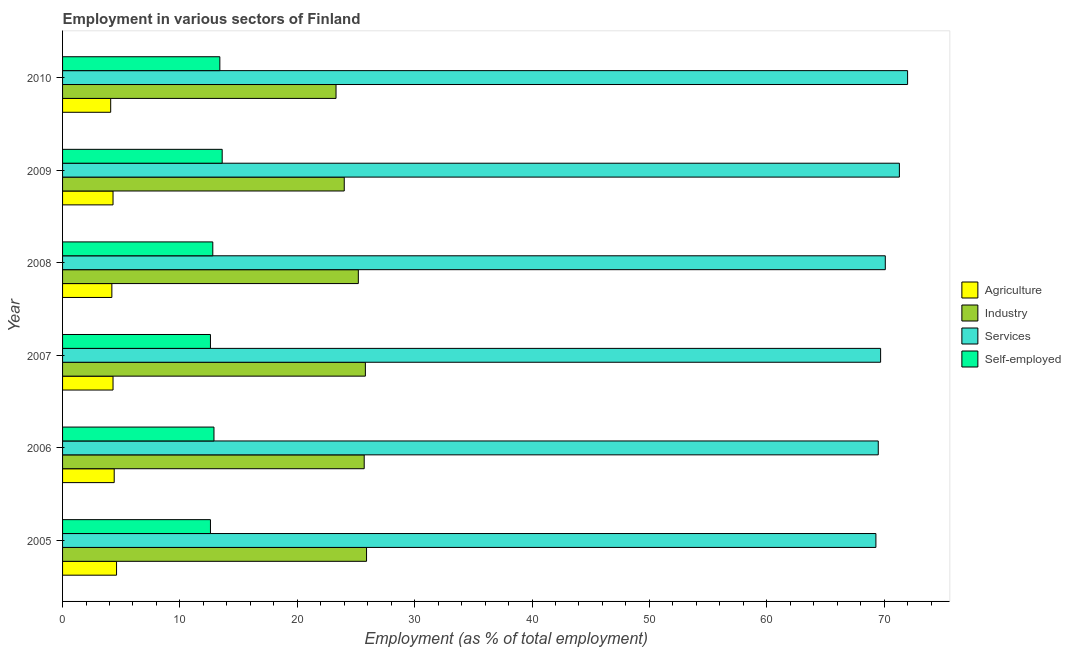How many bars are there on the 5th tick from the bottom?
Provide a succinct answer. 4. What is the percentage of workers in industry in 2005?
Your response must be concise. 25.9. Across all years, what is the maximum percentage of workers in industry?
Your response must be concise. 25.9. Across all years, what is the minimum percentage of workers in services?
Provide a short and direct response. 69.3. In which year was the percentage of workers in agriculture minimum?
Keep it short and to the point. 2010. What is the total percentage of workers in services in the graph?
Keep it short and to the point. 421.9. What is the difference between the percentage of workers in services in 2007 and the percentage of self employed workers in 2006?
Provide a succinct answer. 56.8. What is the average percentage of workers in agriculture per year?
Your response must be concise. 4.32. In the year 2006, what is the difference between the percentage of workers in industry and percentage of workers in agriculture?
Ensure brevity in your answer.  21.3. What is the ratio of the percentage of workers in agriculture in 2009 to that in 2010?
Your response must be concise. 1.05. Is the percentage of workers in agriculture in 2006 less than that in 2010?
Ensure brevity in your answer.  No. What is the difference between the highest and the second highest percentage of workers in industry?
Your response must be concise. 0.1. Is the sum of the percentage of workers in agriculture in 2006 and 2010 greater than the maximum percentage of workers in industry across all years?
Your answer should be compact. No. Is it the case that in every year, the sum of the percentage of workers in agriculture and percentage of workers in services is greater than the sum of percentage of self employed workers and percentage of workers in industry?
Provide a succinct answer. No. What does the 3rd bar from the top in 2010 represents?
Offer a very short reply. Industry. What does the 3rd bar from the bottom in 2010 represents?
Provide a succinct answer. Services. Is it the case that in every year, the sum of the percentage of workers in agriculture and percentage of workers in industry is greater than the percentage of workers in services?
Keep it short and to the point. No. Does the graph contain grids?
Offer a very short reply. No. Where does the legend appear in the graph?
Provide a succinct answer. Center right. How many legend labels are there?
Keep it short and to the point. 4. What is the title of the graph?
Offer a very short reply. Employment in various sectors of Finland. Does "Offering training" appear as one of the legend labels in the graph?
Your answer should be compact. No. What is the label or title of the X-axis?
Your response must be concise. Employment (as % of total employment). What is the Employment (as % of total employment) of Agriculture in 2005?
Make the answer very short. 4.6. What is the Employment (as % of total employment) of Industry in 2005?
Your response must be concise. 25.9. What is the Employment (as % of total employment) of Services in 2005?
Your answer should be compact. 69.3. What is the Employment (as % of total employment) in Self-employed in 2005?
Your answer should be very brief. 12.6. What is the Employment (as % of total employment) in Agriculture in 2006?
Make the answer very short. 4.4. What is the Employment (as % of total employment) of Industry in 2006?
Ensure brevity in your answer.  25.7. What is the Employment (as % of total employment) of Services in 2006?
Ensure brevity in your answer.  69.5. What is the Employment (as % of total employment) in Self-employed in 2006?
Your response must be concise. 12.9. What is the Employment (as % of total employment) in Agriculture in 2007?
Ensure brevity in your answer.  4.3. What is the Employment (as % of total employment) of Industry in 2007?
Give a very brief answer. 25.8. What is the Employment (as % of total employment) of Services in 2007?
Your answer should be compact. 69.7. What is the Employment (as % of total employment) in Self-employed in 2007?
Keep it short and to the point. 12.6. What is the Employment (as % of total employment) of Agriculture in 2008?
Keep it short and to the point. 4.2. What is the Employment (as % of total employment) in Industry in 2008?
Your answer should be compact. 25.2. What is the Employment (as % of total employment) of Services in 2008?
Make the answer very short. 70.1. What is the Employment (as % of total employment) in Self-employed in 2008?
Your response must be concise. 12.8. What is the Employment (as % of total employment) in Agriculture in 2009?
Ensure brevity in your answer.  4.3. What is the Employment (as % of total employment) in Services in 2009?
Provide a succinct answer. 71.3. What is the Employment (as % of total employment) in Self-employed in 2009?
Make the answer very short. 13.6. What is the Employment (as % of total employment) in Agriculture in 2010?
Your response must be concise. 4.1. What is the Employment (as % of total employment) in Industry in 2010?
Give a very brief answer. 23.3. What is the Employment (as % of total employment) of Services in 2010?
Your answer should be very brief. 72. What is the Employment (as % of total employment) of Self-employed in 2010?
Provide a short and direct response. 13.4. Across all years, what is the maximum Employment (as % of total employment) in Agriculture?
Your answer should be compact. 4.6. Across all years, what is the maximum Employment (as % of total employment) of Industry?
Provide a succinct answer. 25.9. Across all years, what is the maximum Employment (as % of total employment) of Services?
Give a very brief answer. 72. Across all years, what is the maximum Employment (as % of total employment) of Self-employed?
Your answer should be compact. 13.6. Across all years, what is the minimum Employment (as % of total employment) in Agriculture?
Make the answer very short. 4.1. Across all years, what is the minimum Employment (as % of total employment) of Industry?
Provide a succinct answer. 23.3. Across all years, what is the minimum Employment (as % of total employment) in Services?
Provide a succinct answer. 69.3. Across all years, what is the minimum Employment (as % of total employment) in Self-employed?
Provide a succinct answer. 12.6. What is the total Employment (as % of total employment) of Agriculture in the graph?
Your answer should be very brief. 25.9. What is the total Employment (as % of total employment) of Industry in the graph?
Provide a succinct answer. 149.9. What is the total Employment (as % of total employment) of Services in the graph?
Keep it short and to the point. 421.9. What is the total Employment (as % of total employment) in Self-employed in the graph?
Your answer should be compact. 77.9. What is the difference between the Employment (as % of total employment) in Agriculture in 2005 and that in 2006?
Provide a succinct answer. 0.2. What is the difference between the Employment (as % of total employment) of Industry in 2005 and that in 2006?
Your response must be concise. 0.2. What is the difference between the Employment (as % of total employment) of Services in 2005 and that in 2006?
Offer a very short reply. -0.2. What is the difference between the Employment (as % of total employment) of Self-employed in 2005 and that in 2008?
Ensure brevity in your answer.  -0.2. What is the difference between the Employment (as % of total employment) in Agriculture in 2005 and that in 2009?
Keep it short and to the point. 0.3. What is the difference between the Employment (as % of total employment) in Industry in 2005 and that in 2009?
Provide a short and direct response. 1.9. What is the difference between the Employment (as % of total employment) of Services in 2005 and that in 2009?
Offer a very short reply. -2. What is the difference between the Employment (as % of total employment) in Self-employed in 2005 and that in 2009?
Your response must be concise. -1. What is the difference between the Employment (as % of total employment) of Agriculture in 2005 and that in 2010?
Make the answer very short. 0.5. What is the difference between the Employment (as % of total employment) of Industry in 2005 and that in 2010?
Your response must be concise. 2.6. What is the difference between the Employment (as % of total employment) of Services in 2005 and that in 2010?
Provide a short and direct response. -2.7. What is the difference between the Employment (as % of total employment) of Self-employed in 2005 and that in 2010?
Provide a short and direct response. -0.8. What is the difference between the Employment (as % of total employment) in Agriculture in 2006 and that in 2007?
Make the answer very short. 0.1. What is the difference between the Employment (as % of total employment) of Industry in 2006 and that in 2007?
Make the answer very short. -0.1. What is the difference between the Employment (as % of total employment) of Services in 2006 and that in 2007?
Your answer should be compact. -0.2. What is the difference between the Employment (as % of total employment) in Agriculture in 2006 and that in 2008?
Your answer should be compact. 0.2. What is the difference between the Employment (as % of total employment) of Industry in 2006 and that in 2008?
Your answer should be very brief. 0.5. What is the difference between the Employment (as % of total employment) in Self-employed in 2006 and that in 2009?
Your answer should be very brief. -0.7. What is the difference between the Employment (as % of total employment) of Agriculture in 2006 and that in 2010?
Your response must be concise. 0.3. What is the difference between the Employment (as % of total employment) of Industry in 2006 and that in 2010?
Offer a very short reply. 2.4. What is the difference between the Employment (as % of total employment) of Self-employed in 2007 and that in 2008?
Keep it short and to the point. -0.2. What is the difference between the Employment (as % of total employment) of Industry in 2007 and that in 2009?
Your answer should be very brief. 1.8. What is the difference between the Employment (as % of total employment) in Services in 2007 and that in 2009?
Provide a succinct answer. -1.6. What is the difference between the Employment (as % of total employment) in Self-employed in 2007 and that in 2009?
Ensure brevity in your answer.  -1. What is the difference between the Employment (as % of total employment) of Agriculture in 2007 and that in 2010?
Ensure brevity in your answer.  0.2. What is the difference between the Employment (as % of total employment) in Industry in 2007 and that in 2010?
Make the answer very short. 2.5. What is the difference between the Employment (as % of total employment) in Services in 2007 and that in 2010?
Provide a succinct answer. -2.3. What is the difference between the Employment (as % of total employment) of Agriculture in 2008 and that in 2009?
Offer a terse response. -0.1. What is the difference between the Employment (as % of total employment) in Agriculture in 2008 and that in 2010?
Ensure brevity in your answer.  0.1. What is the difference between the Employment (as % of total employment) in Services in 2009 and that in 2010?
Offer a very short reply. -0.7. What is the difference between the Employment (as % of total employment) of Self-employed in 2009 and that in 2010?
Your answer should be compact. 0.2. What is the difference between the Employment (as % of total employment) of Agriculture in 2005 and the Employment (as % of total employment) of Industry in 2006?
Make the answer very short. -21.1. What is the difference between the Employment (as % of total employment) of Agriculture in 2005 and the Employment (as % of total employment) of Services in 2006?
Your answer should be very brief. -64.9. What is the difference between the Employment (as % of total employment) of Agriculture in 2005 and the Employment (as % of total employment) of Self-employed in 2006?
Offer a terse response. -8.3. What is the difference between the Employment (as % of total employment) in Industry in 2005 and the Employment (as % of total employment) in Services in 2006?
Provide a succinct answer. -43.6. What is the difference between the Employment (as % of total employment) of Services in 2005 and the Employment (as % of total employment) of Self-employed in 2006?
Provide a short and direct response. 56.4. What is the difference between the Employment (as % of total employment) in Agriculture in 2005 and the Employment (as % of total employment) in Industry in 2007?
Give a very brief answer. -21.2. What is the difference between the Employment (as % of total employment) of Agriculture in 2005 and the Employment (as % of total employment) of Services in 2007?
Provide a short and direct response. -65.1. What is the difference between the Employment (as % of total employment) of Industry in 2005 and the Employment (as % of total employment) of Services in 2007?
Keep it short and to the point. -43.8. What is the difference between the Employment (as % of total employment) in Services in 2005 and the Employment (as % of total employment) in Self-employed in 2007?
Make the answer very short. 56.7. What is the difference between the Employment (as % of total employment) of Agriculture in 2005 and the Employment (as % of total employment) of Industry in 2008?
Provide a short and direct response. -20.6. What is the difference between the Employment (as % of total employment) of Agriculture in 2005 and the Employment (as % of total employment) of Services in 2008?
Your response must be concise. -65.5. What is the difference between the Employment (as % of total employment) in Agriculture in 2005 and the Employment (as % of total employment) in Self-employed in 2008?
Offer a terse response. -8.2. What is the difference between the Employment (as % of total employment) of Industry in 2005 and the Employment (as % of total employment) of Services in 2008?
Provide a short and direct response. -44.2. What is the difference between the Employment (as % of total employment) of Industry in 2005 and the Employment (as % of total employment) of Self-employed in 2008?
Your answer should be very brief. 13.1. What is the difference between the Employment (as % of total employment) of Services in 2005 and the Employment (as % of total employment) of Self-employed in 2008?
Your answer should be very brief. 56.5. What is the difference between the Employment (as % of total employment) in Agriculture in 2005 and the Employment (as % of total employment) in Industry in 2009?
Your answer should be very brief. -19.4. What is the difference between the Employment (as % of total employment) in Agriculture in 2005 and the Employment (as % of total employment) in Services in 2009?
Your response must be concise. -66.7. What is the difference between the Employment (as % of total employment) of Industry in 2005 and the Employment (as % of total employment) of Services in 2009?
Ensure brevity in your answer.  -45.4. What is the difference between the Employment (as % of total employment) in Industry in 2005 and the Employment (as % of total employment) in Self-employed in 2009?
Provide a succinct answer. 12.3. What is the difference between the Employment (as % of total employment) in Services in 2005 and the Employment (as % of total employment) in Self-employed in 2009?
Offer a very short reply. 55.7. What is the difference between the Employment (as % of total employment) in Agriculture in 2005 and the Employment (as % of total employment) in Industry in 2010?
Your answer should be very brief. -18.7. What is the difference between the Employment (as % of total employment) of Agriculture in 2005 and the Employment (as % of total employment) of Services in 2010?
Make the answer very short. -67.4. What is the difference between the Employment (as % of total employment) of Industry in 2005 and the Employment (as % of total employment) of Services in 2010?
Provide a succinct answer. -46.1. What is the difference between the Employment (as % of total employment) of Industry in 2005 and the Employment (as % of total employment) of Self-employed in 2010?
Offer a very short reply. 12.5. What is the difference between the Employment (as % of total employment) of Services in 2005 and the Employment (as % of total employment) of Self-employed in 2010?
Offer a terse response. 55.9. What is the difference between the Employment (as % of total employment) of Agriculture in 2006 and the Employment (as % of total employment) of Industry in 2007?
Your answer should be compact. -21.4. What is the difference between the Employment (as % of total employment) of Agriculture in 2006 and the Employment (as % of total employment) of Services in 2007?
Ensure brevity in your answer.  -65.3. What is the difference between the Employment (as % of total employment) in Agriculture in 2006 and the Employment (as % of total employment) in Self-employed in 2007?
Keep it short and to the point. -8.2. What is the difference between the Employment (as % of total employment) in Industry in 2006 and the Employment (as % of total employment) in Services in 2007?
Offer a terse response. -44. What is the difference between the Employment (as % of total employment) in Industry in 2006 and the Employment (as % of total employment) in Self-employed in 2007?
Provide a short and direct response. 13.1. What is the difference between the Employment (as % of total employment) in Services in 2006 and the Employment (as % of total employment) in Self-employed in 2007?
Keep it short and to the point. 56.9. What is the difference between the Employment (as % of total employment) of Agriculture in 2006 and the Employment (as % of total employment) of Industry in 2008?
Your answer should be very brief. -20.8. What is the difference between the Employment (as % of total employment) of Agriculture in 2006 and the Employment (as % of total employment) of Services in 2008?
Ensure brevity in your answer.  -65.7. What is the difference between the Employment (as % of total employment) of Industry in 2006 and the Employment (as % of total employment) of Services in 2008?
Make the answer very short. -44.4. What is the difference between the Employment (as % of total employment) in Services in 2006 and the Employment (as % of total employment) in Self-employed in 2008?
Your answer should be very brief. 56.7. What is the difference between the Employment (as % of total employment) of Agriculture in 2006 and the Employment (as % of total employment) of Industry in 2009?
Offer a very short reply. -19.6. What is the difference between the Employment (as % of total employment) in Agriculture in 2006 and the Employment (as % of total employment) in Services in 2009?
Ensure brevity in your answer.  -66.9. What is the difference between the Employment (as % of total employment) in Industry in 2006 and the Employment (as % of total employment) in Services in 2009?
Provide a succinct answer. -45.6. What is the difference between the Employment (as % of total employment) in Services in 2006 and the Employment (as % of total employment) in Self-employed in 2009?
Your response must be concise. 55.9. What is the difference between the Employment (as % of total employment) in Agriculture in 2006 and the Employment (as % of total employment) in Industry in 2010?
Offer a terse response. -18.9. What is the difference between the Employment (as % of total employment) of Agriculture in 2006 and the Employment (as % of total employment) of Services in 2010?
Make the answer very short. -67.6. What is the difference between the Employment (as % of total employment) in Agriculture in 2006 and the Employment (as % of total employment) in Self-employed in 2010?
Offer a very short reply. -9. What is the difference between the Employment (as % of total employment) in Industry in 2006 and the Employment (as % of total employment) in Services in 2010?
Offer a very short reply. -46.3. What is the difference between the Employment (as % of total employment) of Services in 2006 and the Employment (as % of total employment) of Self-employed in 2010?
Provide a succinct answer. 56.1. What is the difference between the Employment (as % of total employment) in Agriculture in 2007 and the Employment (as % of total employment) in Industry in 2008?
Your answer should be very brief. -20.9. What is the difference between the Employment (as % of total employment) in Agriculture in 2007 and the Employment (as % of total employment) in Services in 2008?
Provide a short and direct response. -65.8. What is the difference between the Employment (as % of total employment) of Agriculture in 2007 and the Employment (as % of total employment) of Self-employed in 2008?
Provide a succinct answer. -8.5. What is the difference between the Employment (as % of total employment) of Industry in 2007 and the Employment (as % of total employment) of Services in 2008?
Your answer should be compact. -44.3. What is the difference between the Employment (as % of total employment) of Industry in 2007 and the Employment (as % of total employment) of Self-employed in 2008?
Provide a succinct answer. 13. What is the difference between the Employment (as % of total employment) in Services in 2007 and the Employment (as % of total employment) in Self-employed in 2008?
Provide a succinct answer. 56.9. What is the difference between the Employment (as % of total employment) of Agriculture in 2007 and the Employment (as % of total employment) of Industry in 2009?
Ensure brevity in your answer.  -19.7. What is the difference between the Employment (as % of total employment) in Agriculture in 2007 and the Employment (as % of total employment) in Services in 2009?
Offer a very short reply. -67. What is the difference between the Employment (as % of total employment) of Industry in 2007 and the Employment (as % of total employment) of Services in 2009?
Offer a terse response. -45.5. What is the difference between the Employment (as % of total employment) in Services in 2007 and the Employment (as % of total employment) in Self-employed in 2009?
Make the answer very short. 56.1. What is the difference between the Employment (as % of total employment) in Agriculture in 2007 and the Employment (as % of total employment) in Industry in 2010?
Offer a terse response. -19. What is the difference between the Employment (as % of total employment) in Agriculture in 2007 and the Employment (as % of total employment) in Services in 2010?
Your answer should be very brief. -67.7. What is the difference between the Employment (as % of total employment) of Industry in 2007 and the Employment (as % of total employment) of Services in 2010?
Give a very brief answer. -46.2. What is the difference between the Employment (as % of total employment) of Services in 2007 and the Employment (as % of total employment) of Self-employed in 2010?
Offer a terse response. 56.3. What is the difference between the Employment (as % of total employment) of Agriculture in 2008 and the Employment (as % of total employment) of Industry in 2009?
Keep it short and to the point. -19.8. What is the difference between the Employment (as % of total employment) of Agriculture in 2008 and the Employment (as % of total employment) of Services in 2009?
Provide a short and direct response. -67.1. What is the difference between the Employment (as % of total employment) in Industry in 2008 and the Employment (as % of total employment) in Services in 2009?
Provide a succinct answer. -46.1. What is the difference between the Employment (as % of total employment) of Services in 2008 and the Employment (as % of total employment) of Self-employed in 2009?
Your answer should be compact. 56.5. What is the difference between the Employment (as % of total employment) of Agriculture in 2008 and the Employment (as % of total employment) of Industry in 2010?
Offer a terse response. -19.1. What is the difference between the Employment (as % of total employment) in Agriculture in 2008 and the Employment (as % of total employment) in Services in 2010?
Offer a terse response. -67.8. What is the difference between the Employment (as % of total employment) of Agriculture in 2008 and the Employment (as % of total employment) of Self-employed in 2010?
Your response must be concise. -9.2. What is the difference between the Employment (as % of total employment) of Industry in 2008 and the Employment (as % of total employment) of Services in 2010?
Offer a terse response. -46.8. What is the difference between the Employment (as % of total employment) of Services in 2008 and the Employment (as % of total employment) of Self-employed in 2010?
Keep it short and to the point. 56.7. What is the difference between the Employment (as % of total employment) in Agriculture in 2009 and the Employment (as % of total employment) in Industry in 2010?
Offer a terse response. -19. What is the difference between the Employment (as % of total employment) in Agriculture in 2009 and the Employment (as % of total employment) in Services in 2010?
Provide a short and direct response. -67.7. What is the difference between the Employment (as % of total employment) of Industry in 2009 and the Employment (as % of total employment) of Services in 2010?
Your response must be concise. -48. What is the difference between the Employment (as % of total employment) of Services in 2009 and the Employment (as % of total employment) of Self-employed in 2010?
Your answer should be compact. 57.9. What is the average Employment (as % of total employment) in Agriculture per year?
Your response must be concise. 4.32. What is the average Employment (as % of total employment) in Industry per year?
Your response must be concise. 24.98. What is the average Employment (as % of total employment) in Services per year?
Your response must be concise. 70.32. What is the average Employment (as % of total employment) of Self-employed per year?
Provide a succinct answer. 12.98. In the year 2005, what is the difference between the Employment (as % of total employment) of Agriculture and Employment (as % of total employment) of Industry?
Offer a very short reply. -21.3. In the year 2005, what is the difference between the Employment (as % of total employment) in Agriculture and Employment (as % of total employment) in Services?
Keep it short and to the point. -64.7. In the year 2005, what is the difference between the Employment (as % of total employment) in Agriculture and Employment (as % of total employment) in Self-employed?
Offer a terse response. -8. In the year 2005, what is the difference between the Employment (as % of total employment) of Industry and Employment (as % of total employment) of Services?
Make the answer very short. -43.4. In the year 2005, what is the difference between the Employment (as % of total employment) of Services and Employment (as % of total employment) of Self-employed?
Provide a short and direct response. 56.7. In the year 2006, what is the difference between the Employment (as % of total employment) of Agriculture and Employment (as % of total employment) of Industry?
Make the answer very short. -21.3. In the year 2006, what is the difference between the Employment (as % of total employment) of Agriculture and Employment (as % of total employment) of Services?
Your response must be concise. -65.1. In the year 2006, what is the difference between the Employment (as % of total employment) in Agriculture and Employment (as % of total employment) in Self-employed?
Your answer should be very brief. -8.5. In the year 2006, what is the difference between the Employment (as % of total employment) of Industry and Employment (as % of total employment) of Services?
Give a very brief answer. -43.8. In the year 2006, what is the difference between the Employment (as % of total employment) in Services and Employment (as % of total employment) in Self-employed?
Provide a succinct answer. 56.6. In the year 2007, what is the difference between the Employment (as % of total employment) of Agriculture and Employment (as % of total employment) of Industry?
Give a very brief answer. -21.5. In the year 2007, what is the difference between the Employment (as % of total employment) of Agriculture and Employment (as % of total employment) of Services?
Offer a terse response. -65.4. In the year 2007, what is the difference between the Employment (as % of total employment) of Agriculture and Employment (as % of total employment) of Self-employed?
Offer a terse response. -8.3. In the year 2007, what is the difference between the Employment (as % of total employment) of Industry and Employment (as % of total employment) of Services?
Keep it short and to the point. -43.9. In the year 2007, what is the difference between the Employment (as % of total employment) in Industry and Employment (as % of total employment) in Self-employed?
Offer a terse response. 13.2. In the year 2007, what is the difference between the Employment (as % of total employment) in Services and Employment (as % of total employment) in Self-employed?
Your answer should be very brief. 57.1. In the year 2008, what is the difference between the Employment (as % of total employment) in Agriculture and Employment (as % of total employment) in Services?
Provide a short and direct response. -65.9. In the year 2008, what is the difference between the Employment (as % of total employment) in Agriculture and Employment (as % of total employment) in Self-employed?
Your answer should be very brief. -8.6. In the year 2008, what is the difference between the Employment (as % of total employment) of Industry and Employment (as % of total employment) of Services?
Give a very brief answer. -44.9. In the year 2008, what is the difference between the Employment (as % of total employment) in Services and Employment (as % of total employment) in Self-employed?
Offer a terse response. 57.3. In the year 2009, what is the difference between the Employment (as % of total employment) of Agriculture and Employment (as % of total employment) of Industry?
Offer a very short reply. -19.7. In the year 2009, what is the difference between the Employment (as % of total employment) of Agriculture and Employment (as % of total employment) of Services?
Provide a short and direct response. -67. In the year 2009, what is the difference between the Employment (as % of total employment) in Agriculture and Employment (as % of total employment) in Self-employed?
Your answer should be compact. -9.3. In the year 2009, what is the difference between the Employment (as % of total employment) of Industry and Employment (as % of total employment) of Services?
Keep it short and to the point. -47.3. In the year 2009, what is the difference between the Employment (as % of total employment) in Services and Employment (as % of total employment) in Self-employed?
Your answer should be very brief. 57.7. In the year 2010, what is the difference between the Employment (as % of total employment) of Agriculture and Employment (as % of total employment) of Industry?
Give a very brief answer. -19.2. In the year 2010, what is the difference between the Employment (as % of total employment) of Agriculture and Employment (as % of total employment) of Services?
Offer a terse response. -67.9. In the year 2010, what is the difference between the Employment (as % of total employment) in Agriculture and Employment (as % of total employment) in Self-employed?
Make the answer very short. -9.3. In the year 2010, what is the difference between the Employment (as % of total employment) of Industry and Employment (as % of total employment) of Services?
Offer a very short reply. -48.7. In the year 2010, what is the difference between the Employment (as % of total employment) in Services and Employment (as % of total employment) in Self-employed?
Provide a succinct answer. 58.6. What is the ratio of the Employment (as % of total employment) of Agriculture in 2005 to that in 2006?
Give a very brief answer. 1.05. What is the ratio of the Employment (as % of total employment) in Industry in 2005 to that in 2006?
Offer a terse response. 1.01. What is the ratio of the Employment (as % of total employment) in Self-employed in 2005 to that in 2006?
Provide a short and direct response. 0.98. What is the ratio of the Employment (as % of total employment) in Agriculture in 2005 to that in 2007?
Offer a very short reply. 1.07. What is the ratio of the Employment (as % of total employment) of Agriculture in 2005 to that in 2008?
Your answer should be very brief. 1.1. What is the ratio of the Employment (as % of total employment) in Industry in 2005 to that in 2008?
Offer a terse response. 1.03. What is the ratio of the Employment (as % of total employment) of Self-employed in 2005 to that in 2008?
Give a very brief answer. 0.98. What is the ratio of the Employment (as % of total employment) of Agriculture in 2005 to that in 2009?
Ensure brevity in your answer.  1.07. What is the ratio of the Employment (as % of total employment) of Industry in 2005 to that in 2009?
Your response must be concise. 1.08. What is the ratio of the Employment (as % of total employment) in Services in 2005 to that in 2009?
Provide a short and direct response. 0.97. What is the ratio of the Employment (as % of total employment) in Self-employed in 2005 to that in 2009?
Provide a succinct answer. 0.93. What is the ratio of the Employment (as % of total employment) in Agriculture in 2005 to that in 2010?
Your answer should be very brief. 1.12. What is the ratio of the Employment (as % of total employment) in Industry in 2005 to that in 2010?
Give a very brief answer. 1.11. What is the ratio of the Employment (as % of total employment) in Services in 2005 to that in 2010?
Offer a terse response. 0.96. What is the ratio of the Employment (as % of total employment) of Self-employed in 2005 to that in 2010?
Ensure brevity in your answer.  0.94. What is the ratio of the Employment (as % of total employment) of Agriculture in 2006 to that in 2007?
Provide a short and direct response. 1.02. What is the ratio of the Employment (as % of total employment) of Services in 2006 to that in 2007?
Your response must be concise. 1. What is the ratio of the Employment (as % of total employment) in Self-employed in 2006 to that in 2007?
Offer a very short reply. 1.02. What is the ratio of the Employment (as % of total employment) in Agriculture in 2006 to that in 2008?
Offer a terse response. 1.05. What is the ratio of the Employment (as % of total employment) of Industry in 2006 to that in 2008?
Keep it short and to the point. 1.02. What is the ratio of the Employment (as % of total employment) of Self-employed in 2006 to that in 2008?
Your answer should be very brief. 1.01. What is the ratio of the Employment (as % of total employment) of Agriculture in 2006 to that in 2009?
Your response must be concise. 1.02. What is the ratio of the Employment (as % of total employment) in Industry in 2006 to that in 2009?
Keep it short and to the point. 1.07. What is the ratio of the Employment (as % of total employment) in Services in 2006 to that in 2009?
Provide a succinct answer. 0.97. What is the ratio of the Employment (as % of total employment) of Self-employed in 2006 to that in 2009?
Your answer should be compact. 0.95. What is the ratio of the Employment (as % of total employment) in Agriculture in 2006 to that in 2010?
Keep it short and to the point. 1.07. What is the ratio of the Employment (as % of total employment) in Industry in 2006 to that in 2010?
Keep it short and to the point. 1.1. What is the ratio of the Employment (as % of total employment) in Services in 2006 to that in 2010?
Offer a very short reply. 0.97. What is the ratio of the Employment (as % of total employment) of Self-employed in 2006 to that in 2010?
Keep it short and to the point. 0.96. What is the ratio of the Employment (as % of total employment) of Agriculture in 2007 to that in 2008?
Offer a terse response. 1.02. What is the ratio of the Employment (as % of total employment) of Industry in 2007 to that in 2008?
Make the answer very short. 1.02. What is the ratio of the Employment (as % of total employment) of Self-employed in 2007 to that in 2008?
Keep it short and to the point. 0.98. What is the ratio of the Employment (as % of total employment) of Industry in 2007 to that in 2009?
Give a very brief answer. 1.07. What is the ratio of the Employment (as % of total employment) in Services in 2007 to that in 2009?
Ensure brevity in your answer.  0.98. What is the ratio of the Employment (as % of total employment) of Self-employed in 2007 to that in 2009?
Make the answer very short. 0.93. What is the ratio of the Employment (as % of total employment) in Agriculture in 2007 to that in 2010?
Make the answer very short. 1.05. What is the ratio of the Employment (as % of total employment) in Industry in 2007 to that in 2010?
Provide a succinct answer. 1.11. What is the ratio of the Employment (as % of total employment) of Services in 2007 to that in 2010?
Provide a short and direct response. 0.97. What is the ratio of the Employment (as % of total employment) of Self-employed in 2007 to that in 2010?
Your answer should be compact. 0.94. What is the ratio of the Employment (as % of total employment) of Agriculture in 2008 to that in 2009?
Make the answer very short. 0.98. What is the ratio of the Employment (as % of total employment) in Services in 2008 to that in 2009?
Provide a short and direct response. 0.98. What is the ratio of the Employment (as % of total employment) in Agriculture in 2008 to that in 2010?
Provide a short and direct response. 1.02. What is the ratio of the Employment (as % of total employment) of Industry in 2008 to that in 2010?
Provide a succinct answer. 1.08. What is the ratio of the Employment (as % of total employment) in Services in 2008 to that in 2010?
Provide a short and direct response. 0.97. What is the ratio of the Employment (as % of total employment) in Self-employed in 2008 to that in 2010?
Offer a very short reply. 0.96. What is the ratio of the Employment (as % of total employment) of Agriculture in 2009 to that in 2010?
Your response must be concise. 1.05. What is the ratio of the Employment (as % of total employment) of Services in 2009 to that in 2010?
Make the answer very short. 0.99. What is the ratio of the Employment (as % of total employment) of Self-employed in 2009 to that in 2010?
Your response must be concise. 1.01. What is the difference between the highest and the second highest Employment (as % of total employment) of Agriculture?
Give a very brief answer. 0.2. What is the difference between the highest and the second highest Employment (as % of total employment) in Self-employed?
Provide a succinct answer. 0.2. What is the difference between the highest and the lowest Employment (as % of total employment) of Industry?
Provide a short and direct response. 2.6. What is the difference between the highest and the lowest Employment (as % of total employment) in Services?
Give a very brief answer. 2.7. What is the difference between the highest and the lowest Employment (as % of total employment) of Self-employed?
Ensure brevity in your answer.  1. 